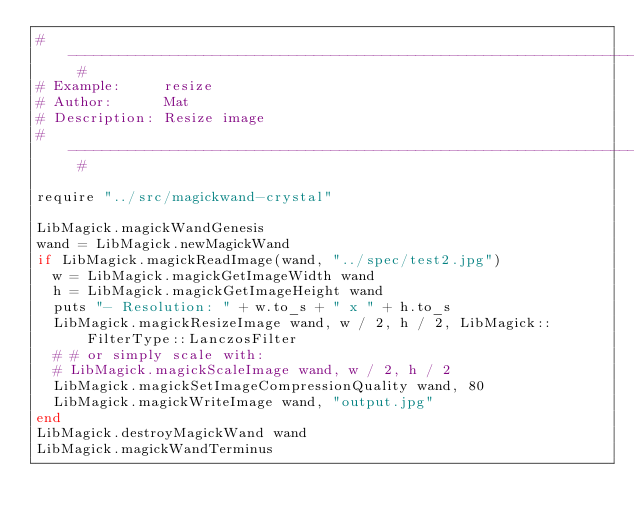Convert code to text. <code><loc_0><loc_0><loc_500><loc_500><_Crystal_># ---------------------------------------------------------------------------- #
# Example:     resize
# Author:      Mat
# Description: Resize image
# ---------------------------------------------------------------------------- #

require "../src/magickwand-crystal"

LibMagick.magickWandGenesis
wand = LibMagick.newMagickWand
if LibMagick.magickReadImage(wand, "../spec/test2.jpg")
  w = LibMagick.magickGetImageWidth wand
  h = LibMagick.magickGetImageHeight wand
  puts "- Resolution: " + w.to_s + " x " + h.to_s
  LibMagick.magickResizeImage wand, w / 2, h / 2, LibMagick::FilterType::LanczosFilter
  # # or simply scale with:
  # LibMagick.magickScaleImage wand, w / 2, h / 2
  LibMagick.magickSetImageCompressionQuality wand, 80
  LibMagick.magickWriteImage wand, "output.jpg"
end
LibMagick.destroyMagickWand wand
LibMagick.magickWandTerminus
</code> 